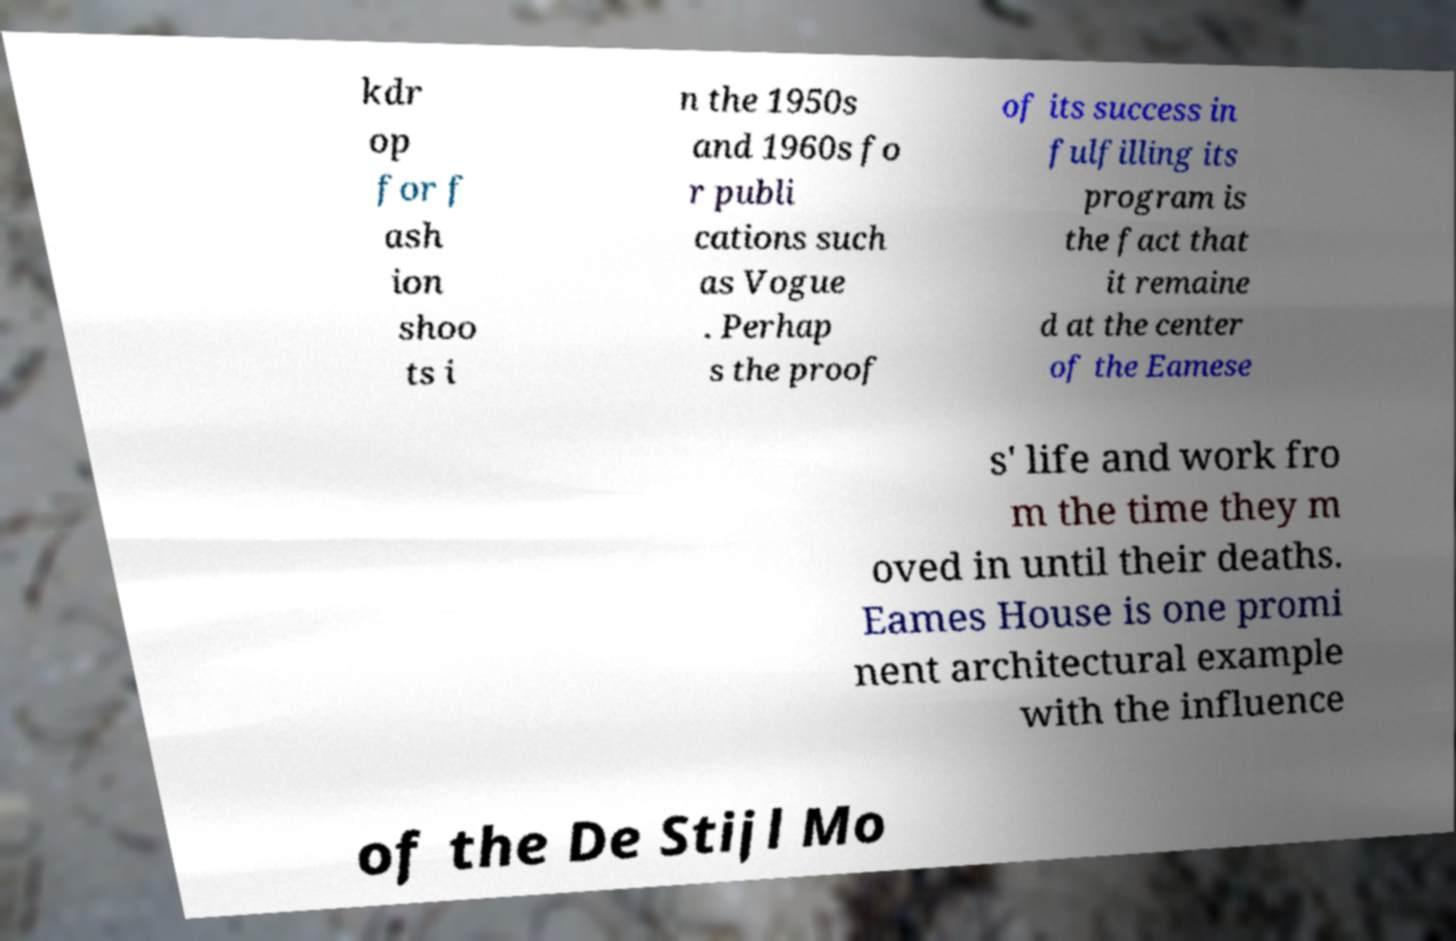Please identify and transcribe the text found in this image. kdr op for f ash ion shoo ts i n the 1950s and 1960s fo r publi cations such as Vogue . Perhap s the proof of its success in fulfilling its program is the fact that it remaine d at the center of the Eamese s' life and work fro m the time they m oved in until their deaths. Eames House is one promi nent architectural example with the influence of the De Stijl Mo 